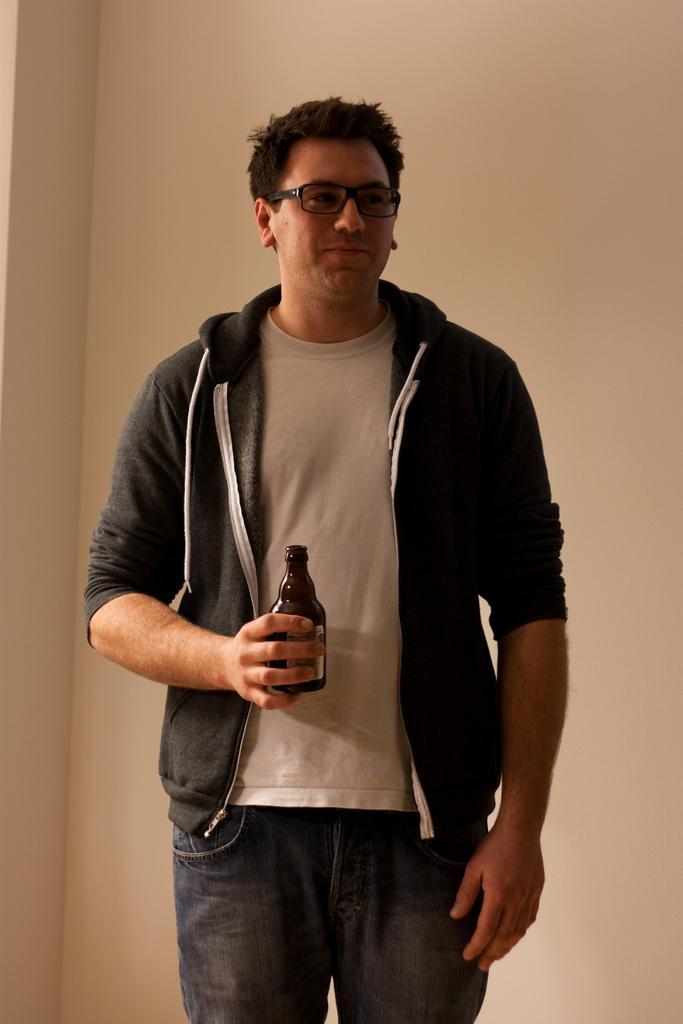Please provide a concise description of this image. In this picture there is a man wearing black jacket and holding a bottle in his right hand. 